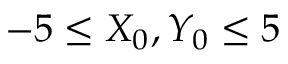Convert formula to latex. <formula><loc_0><loc_0><loc_500><loc_500>- 5 \leq X _ { 0 } , Y _ { 0 } \leq 5</formula> 